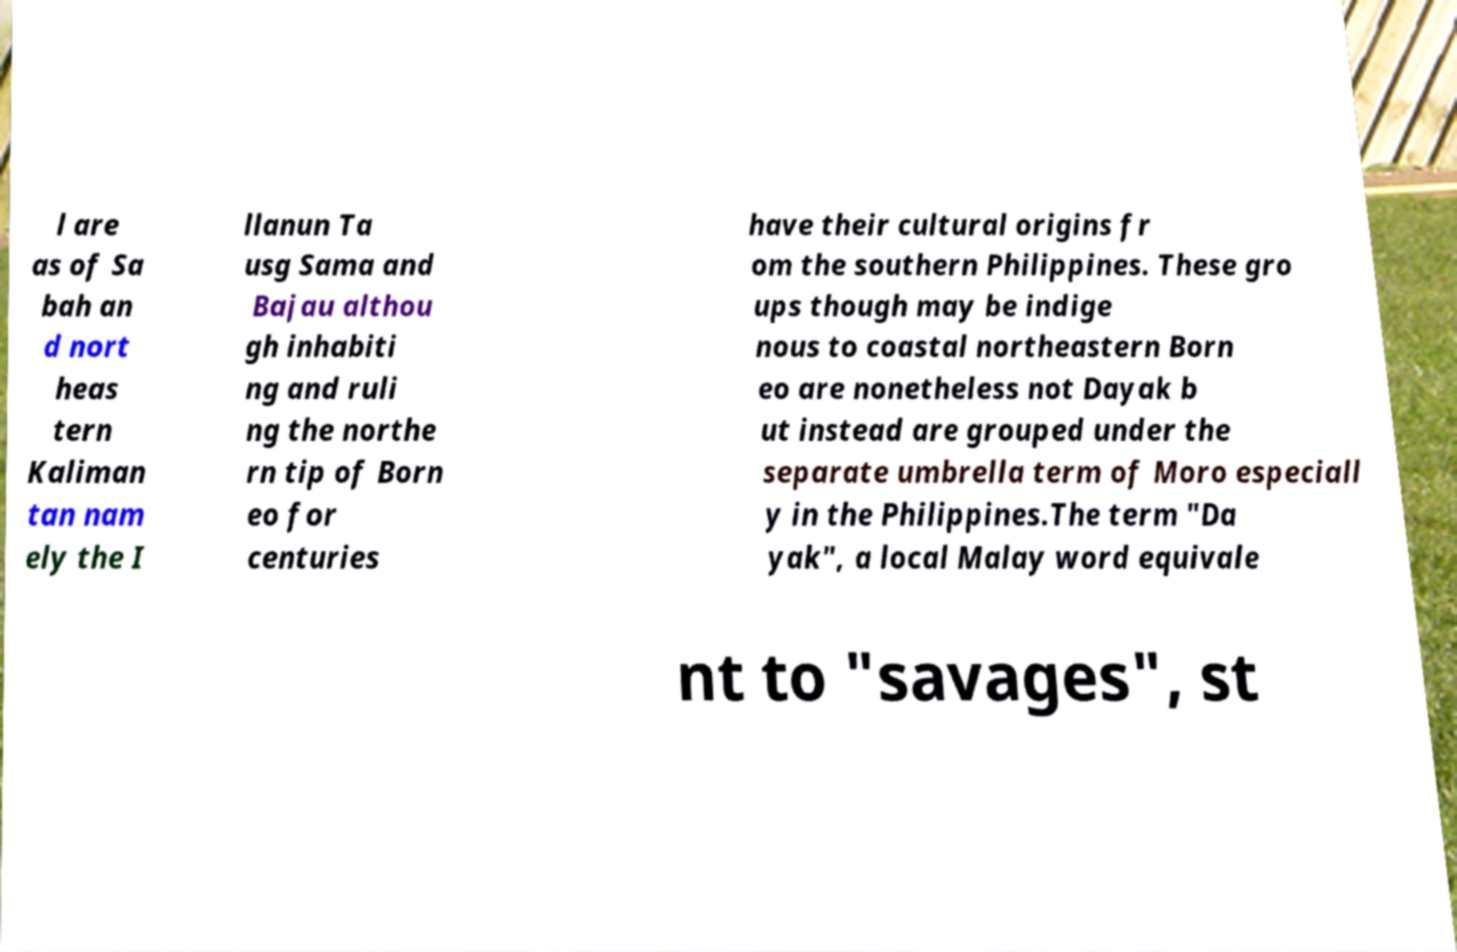Could you extract and type out the text from this image? l are as of Sa bah an d nort heas tern Kaliman tan nam ely the I llanun Ta usg Sama and Bajau althou gh inhabiti ng and ruli ng the northe rn tip of Born eo for centuries have their cultural origins fr om the southern Philippines. These gro ups though may be indige nous to coastal northeastern Born eo are nonetheless not Dayak b ut instead are grouped under the separate umbrella term of Moro especiall y in the Philippines.The term "Da yak", a local Malay word equivale nt to "savages", st 